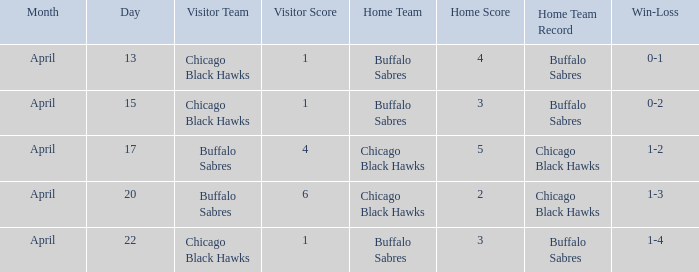Which Home is on april 22? Buffalo Sabres. 